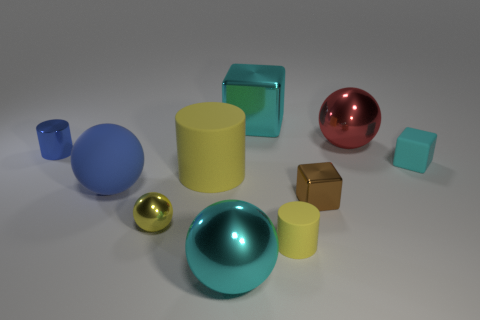Subtract all purple spheres. Subtract all yellow blocks. How many spheres are left? 4 Subtract all cubes. How many objects are left? 7 Add 5 small yellow balls. How many small yellow balls exist? 6 Subtract 0 purple cylinders. How many objects are left? 10 Subtract all tiny gray matte blocks. Subtract all small brown metal objects. How many objects are left? 9 Add 5 red things. How many red things are left? 6 